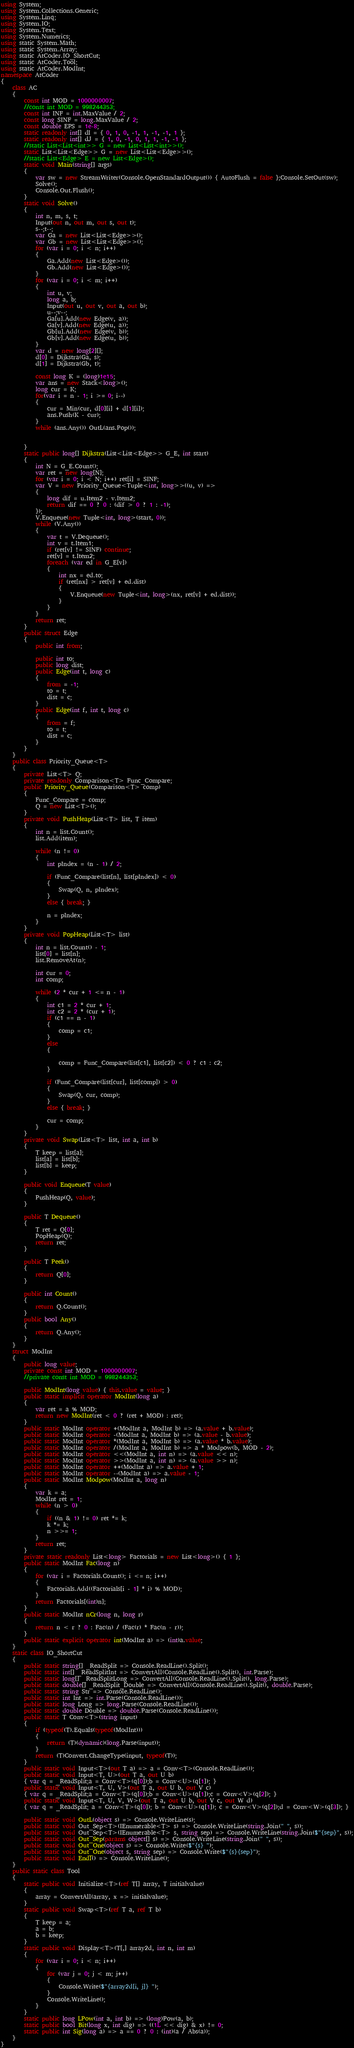Convert code to text. <code><loc_0><loc_0><loc_500><loc_500><_C#_>using System;
using System.Collections.Generic;
using System.Linq;
using System.IO;
using System.Text;
using System.Numerics;
using static System.Math;
using static System.Array;
using static AtCoder.IO_ShortCut;
using static AtCoder.Tool;
using static AtCoder.ModInt;
namespace AtCoder
{
    class AC
    {
        const int MOD = 1000000007;
        //const int MOD = 998244353;
        const int INF = int.MaxValue / 2;
        const long SINF = long.MaxValue / 2;
        const double EPS = 1e-8;
        static readonly int[] dI = { 0, 1, 0, -1, 1, -1, -1, 1 };
        static readonly int[] dJ = { 1, 0, -1, 0, 1, 1, -1, -1 };
        //static List<List<int>> G = new List<List<int>>();
        static List<List<Edge>> G = new List<List<Edge>>();
        //static List<Edge> E = new List<Edge>();
        static void Main(string[] args)
        {
            var sw = new StreamWriter(Console.OpenStandardOutput()) { AutoFlush = false };Console.SetOut(sw);
            Solve();
            Console.Out.Flush();
        }
        static void Solve()
        {
            int n, m, s, t;
            Input(out n, out m, out s, out t);
            s--;t--;
            var Ga = new List<List<Edge>>();
            var Gb = new List<List<Edge>>();
            for (var i = 0; i < n; i++)
            {
                Ga.Add(new List<Edge>());
                Gb.Add(new List<Edge>());
            }
            for (var i = 0; i < m; i++)
            {
                int u, v;
                long a, b;
                Input(out u, out v, out a, out b);
                u--;v--;
                Ga[u].Add(new Edge(v, a));
                Ga[v].Add(new Edge(u, a));
                Gb[u].Add(new Edge(v, b));
                Gb[v].Add(new Edge(u, b));
            }
            var d = new long[2][];
            d[0] = Dijkstra(Ga, s);
            d[1] = Dijkstra(Gb, t);

            const long K = (long)1e15;
            var ans = new Stack<long>();
            long cur = K;
            for(var i = n - 1; i >= 0; i--)
            {
                cur = Min(cur, d[0][i] + d[1][i]);
                ans.Push(K - cur);
            }
            while (ans.Any()) OutL(ans.Pop());


        }
        static public long[] Dijkstra(List<List<Edge>> G_E, int start)
        {
            int N = G_E.Count();
            var ret = new long[N];
            for (var i = 0; i < N; i++) ret[i] = SINF;
            var V = new Priority_Queue<Tuple<int, long>>((u, v) =>
            {
                long dif = u.Item2 - v.Item2;
                return dif == 0 ? 0 : (dif > 0 ? 1 : -1);
            });
            V.Enqueue(new Tuple<int, long>(start, 0));
            while (V.Any())
            {
                var t = V.Dequeue();
                int v = t.Item1;
                if (ret[v] != SINF) continue;
                ret[v] = t.Item2;
                foreach (var ed in G_E[v])
                {
                    int nx = ed.to;
                    if (ret[nx] > ret[v] + ed.dist)
                    {
                        V.Enqueue(new Tuple<int, long>(nx, ret[v] + ed.dist));
                    }
                }
            }
            return ret;
        }
        public struct Edge
        {
            public int from;

            public int to;
            public long dist;
            public Edge(int t, long c)
            {
                from = -1;
                to = t;
                dist = c;
            }
            public Edge(int f, int t, long c)
            {
                from = f;
                to = t;
                dist = c;
            }
        }
    }
    public class Priority_Queue<T>
    {
        private List<T> Q;
        private readonly Comparison<T> Func_Compare;
        public Priority_Queue(Comparison<T> comp)
        {
            Func_Compare = comp;
            Q = new List<T>();
        }
        private void PushHeap(List<T> list, T item)
        {
            int n = list.Count();
            list.Add(item);

            while (n != 0)
            {
                int pIndex = (n - 1) / 2;

                if (Func_Compare(list[n], list[pIndex]) < 0)
                {
                    Swap(Q, n, pIndex);
                }
                else { break; }

                n = pIndex;
            }
        }
        private void PopHeap(List<T> list)
        {
            int n = list.Count() - 1;
            list[0] = list[n];
            list.RemoveAt(n);

            int cur = 0;
            int comp;

            while (2 * cur + 1 <= n - 1)
            {
                int c1 = 2 * cur + 1;
                int c2 = 2 * (cur + 1);
                if (c1 == n - 1)
                {
                    comp = c1;
                }
                else
                {

                    comp = Func_Compare(list[c1], list[c2]) < 0 ? c1 : c2;
                }

                if (Func_Compare(list[cur], list[comp]) > 0)
                {
                    Swap(Q, cur, comp);
                }
                else { break; }

                cur = comp;
            }
        }
        private void Swap(List<T> list, int a, int b)
        {
            T keep = list[a];
            list[a] = list[b];
            list[b] = keep;
        }

        public void Enqueue(T value)
        {
            PushHeap(Q, value);
        }

        public T Dequeue()
        {
            T ret = Q[0];
            PopHeap(Q);
            return ret;
        }

        public T Peek()
        {
            return Q[0];
        }

        public int Count()
        {
            return Q.Count();
        }
        public bool Any()
        {
            return Q.Any();
        }
    }
    struct ModInt
    {
        public long value;
        private const int MOD = 1000000007;
        //private const int MOD = 998244353;

        public ModInt(long value) { this.value = value; }
        public static implicit operator ModInt(long a)
        {
            var ret = a % MOD;
            return new ModInt(ret < 0 ? (ret + MOD) : ret);
        }
        public static ModInt operator +(ModInt a, ModInt b) => (a.value + b.value);
        public static ModInt operator -(ModInt a, ModInt b) => (a.value - b.value);
        public static ModInt operator *(ModInt a, ModInt b) => (a.value * b.value);
        public static ModInt operator /(ModInt a, ModInt b) => a * Modpow(b, MOD - 2);
        public static ModInt operator <<(ModInt a, int n) => (a.value << n);
        public static ModInt operator >>(ModInt a, int n) => (a.value >> n);
        public static ModInt operator ++(ModInt a) => a.value + 1;
        public static ModInt operator --(ModInt a) => a.value - 1;
        public static ModInt Modpow(ModInt a, long n)
        {
            var k = a;
            ModInt ret = 1;
            while (n > 0)
            {
                if ((n & 1) != 0) ret *= k;
                k *= k;
                n >>= 1;
            }
            return ret;
        }
        private static readonly List<long> Factorials = new List<long>() { 1 };
        public static ModInt Fac(long n)
        {
            for (var i = Factorials.Count(); i <= n; i++)
            {
                Factorials.Add((Factorials[i - 1] * i) % MOD);
            }
            return Factorials[(int)n];
        }
        public static ModInt nCr(long n, long r)
        {
            return n < r ? 0 : Fac(n) / (Fac(r) * Fac(n - r));
        }
        public static explicit operator int(ModInt a) => (int)a.value;
    }
    static class IO_ShortCut
    {
        public static string[] _ReadSplit => Console.ReadLine().Split();
        public static int[] _ReadSplitInt => ConvertAll(Console.ReadLine().Split(), int.Parse);
        public static long[] _ReadSplitLong => ConvertAll(Console.ReadLine().Split(), long.Parse);
        public static double[] _ReadSplit_Double => ConvertAll(Console.ReadLine().Split(), double.Parse);
        public static string Str => Console.ReadLine();
        public static int Int => int.Parse(Console.ReadLine());
        public static long Long => long.Parse(Console.ReadLine());
        public static double Double => double.Parse(Console.ReadLine());
        public static T Conv<T>(string input)
        {
            if (typeof(T).Equals(typeof(ModInt)))
            {
                return (T)(dynamic)(long.Parse(input));
            }
            return (T)Convert.ChangeType(input, typeof(T));
        }
        public static void Input<T>(out T a) => a = Conv<T>(Console.ReadLine());
        public static void Input<T, U>(out T a, out U b)
        { var q = _ReadSplit;a = Conv<T>(q[0]);b = Conv<U>(q[1]); }
        public static void Input<T, U, V>(out T a, out U b, out V c)
        { var q = _ReadSplit;a = Conv<T>(q[0]);b = Conv<U>(q[1]);c = Conv<V>(q[2]); }
        public static void Input<T, U, V, W>(out T a, out U b, out V c, out W d)
        { var q = _ReadSplit; a = Conv<T>(q[0]); b = Conv<U>(q[1]); c = Conv<V>(q[2]);d = Conv<W>(q[3]); }

        public static void OutL(object s) => Console.WriteLine(s);
        public static void Out_Sep<T>(IEnumerable<T> s) => Console.WriteLine(string.Join(" ", s));
        public static void Out_Sep<T>(IEnumerable<T> s, string sep) => Console.WriteLine(string.Join($"{sep}", s));
        public static void Out_Sep(params object[] s) => Console.WriteLine(string.Join(" ", s));
        public static void Out_One(object s) => Console.Write($"{s} ");
        public static void Out_One(object s, string sep) => Console.Write($"{s}{sep}");
        public static void Endl() => Console.WriteLine();
    }
    public static class Tool
    {
        static public void Initialize<T>(ref T[] array, T initialvalue)
        {
            array = ConvertAll(array, x => initialvalue);
        }
        static public void Swap<T>(ref T a, ref T b)
        {
            T keep = a;
            a = b;
            b = keep;
        }
        static public void Display<T>(T[,] array2d, int n, int m)
        {
            for (var i = 0; i < n; i++)
            {
                for (var j = 0; j < m; j++)
                {
                    Console.Write($"{array2d[i, j]} ");
                }
                Console.WriteLine();
            }
        }
        static public long LPow(int a, int b) => (long)Pow(a, b);
        static public bool Bit(long x, int dig) => ((1L << dig) & x) != 0;
        static public int Sig(long a) => a == 0 ? 0 : (int)(a / Abs(a));
    }
}</code> 